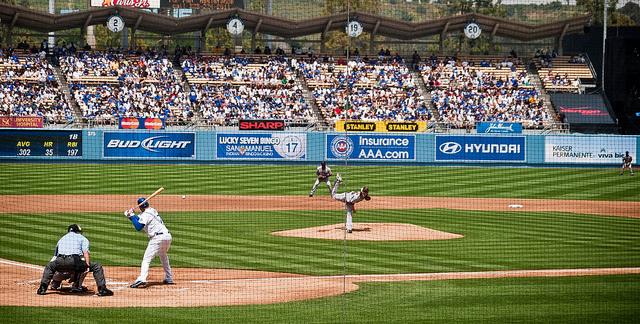Where are the players playing at?
Short answer required. Stadium. Has the batter hit the ball yet?
Answer briefly. No. Is it a bright sunny day?
Write a very short answer. Yes. 